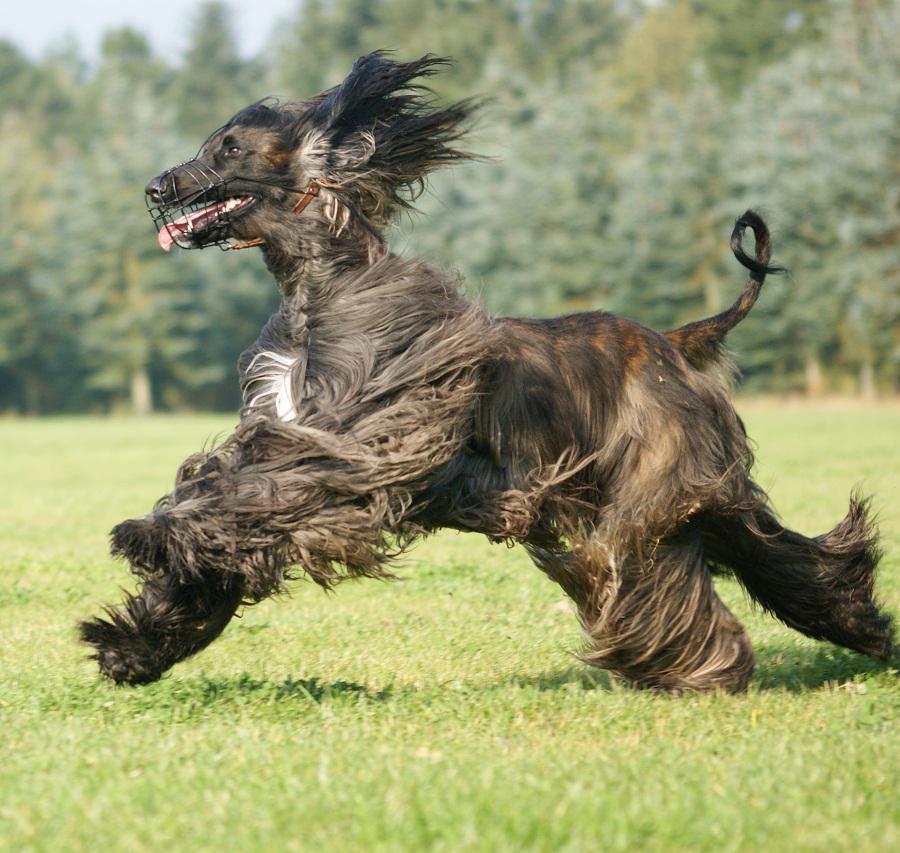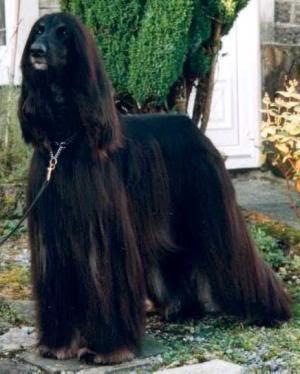The first image is the image on the left, the second image is the image on the right. For the images displayed, is the sentence "The left and right image contains the same number of dogs face left forward." factually correct? Answer yes or no. Yes. 